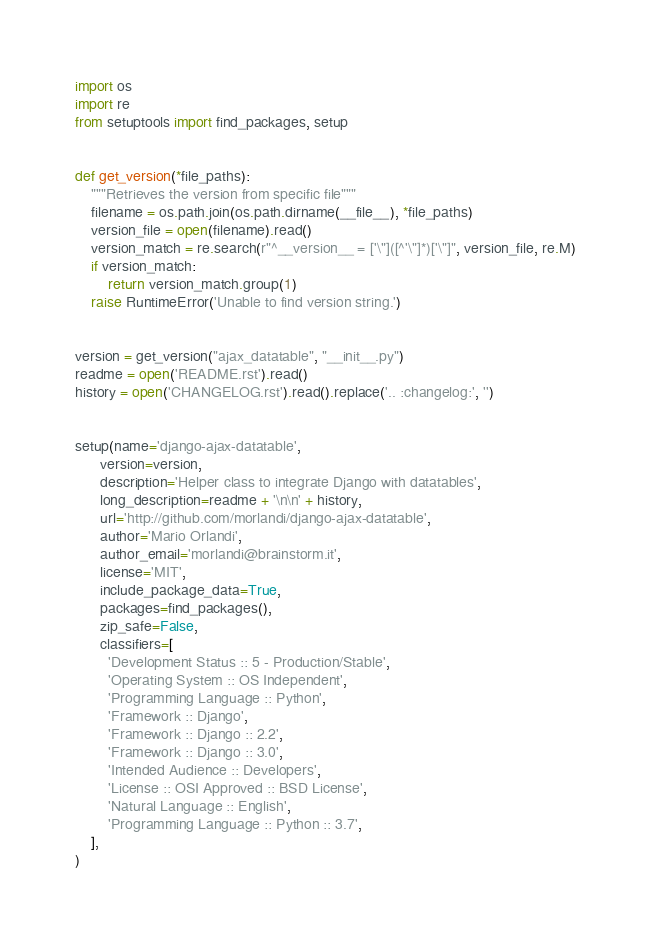Convert code to text. <code><loc_0><loc_0><loc_500><loc_500><_Python_>import os
import re
from setuptools import find_packages, setup


def get_version(*file_paths):
    """Retrieves the version from specific file"""
    filename = os.path.join(os.path.dirname(__file__), *file_paths)
    version_file = open(filename).read()
    version_match = re.search(r"^__version__ = ['\"]([^'\"]*)['\"]", version_file, re.M)
    if version_match:
        return version_match.group(1)
    raise RuntimeError('Unable to find version string.')


version = get_version("ajax_datatable", "__init__.py")
readme = open('README.rst').read()
history = open('CHANGELOG.rst').read().replace('.. :changelog:', '')


setup(name='django-ajax-datatable',
      version=version,
      description='Helper class to integrate Django with datatables',
      long_description=readme + '\n\n' + history,
      url='http://github.com/morlandi/django-ajax-datatable',
      author='Mario Orlandi',
      author_email='morlandi@brainstorm.it',
      license='MIT',
      include_package_data=True,
      packages=find_packages(),
      zip_safe=False,
      classifiers=[
        'Development Status :: 5 - Production/Stable',
        'Operating System :: OS Independent',
        'Programming Language :: Python',
        'Framework :: Django',
        'Framework :: Django :: 2.2',
        'Framework :: Django :: 3.0',
        'Intended Audience :: Developers',
        'License :: OSI Approved :: BSD License',
        'Natural Language :: English',
        'Programming Language :: Python :: 3.7',
    ],
)

</code> 